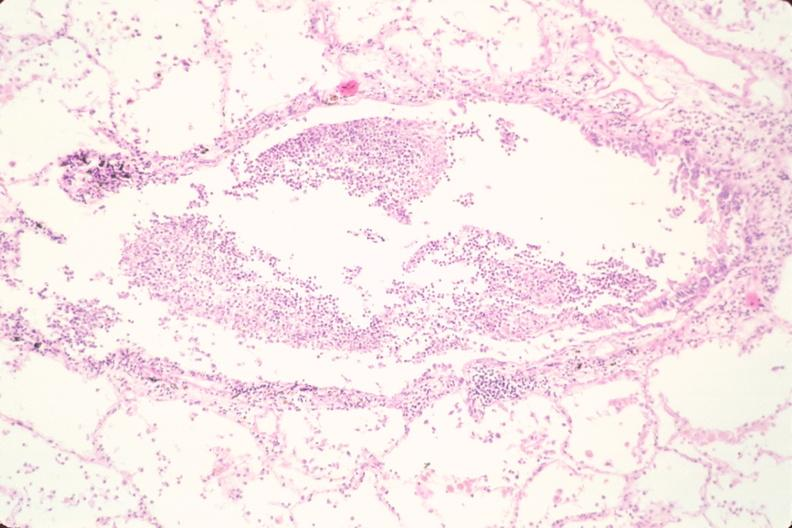where is this?
Answer the question using a single word or phrase. Lung 